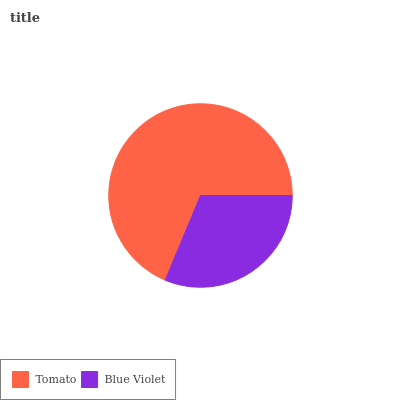Is Blue Violet the minimum?
Answer yes or no. Yes. Is Tomato the maximum?
Answer yes or no. Yes. Is Blue Violet the maximum?
Answer yes or no. No. Is Tomato greater than Blue Violet?
Answer yes or no. Yes. Is Blue Violet less than Tomato?
Answer yes or no. Yes. Is Blue Violet greater than Tomato?
Answer yes or no. No. Is Tomato less than Blue Violet?
Answer yes or no. No. Is Tomato the high median?
Answer yes or no. Yes. Is Blue Violet the low median?
Answer yes or no. Yes. Is Blue Violet the high median?
Answer yes or no. No. Is Tomato the low median?
Answer yes or no. No. 